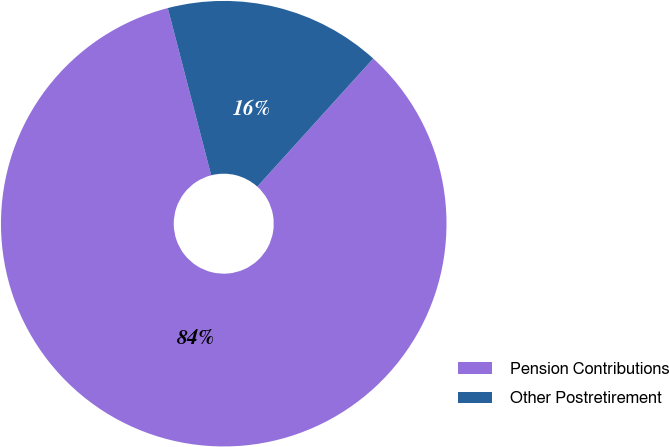Convert chart to OTSL. <chart><loc_0><loc_0><loc_500><loc_500><pie_chart><fcel>Pension Contributions<fcel>Other Postretirement<nl><fcel>84.25%<fcel>15.75%<nl></chart> 